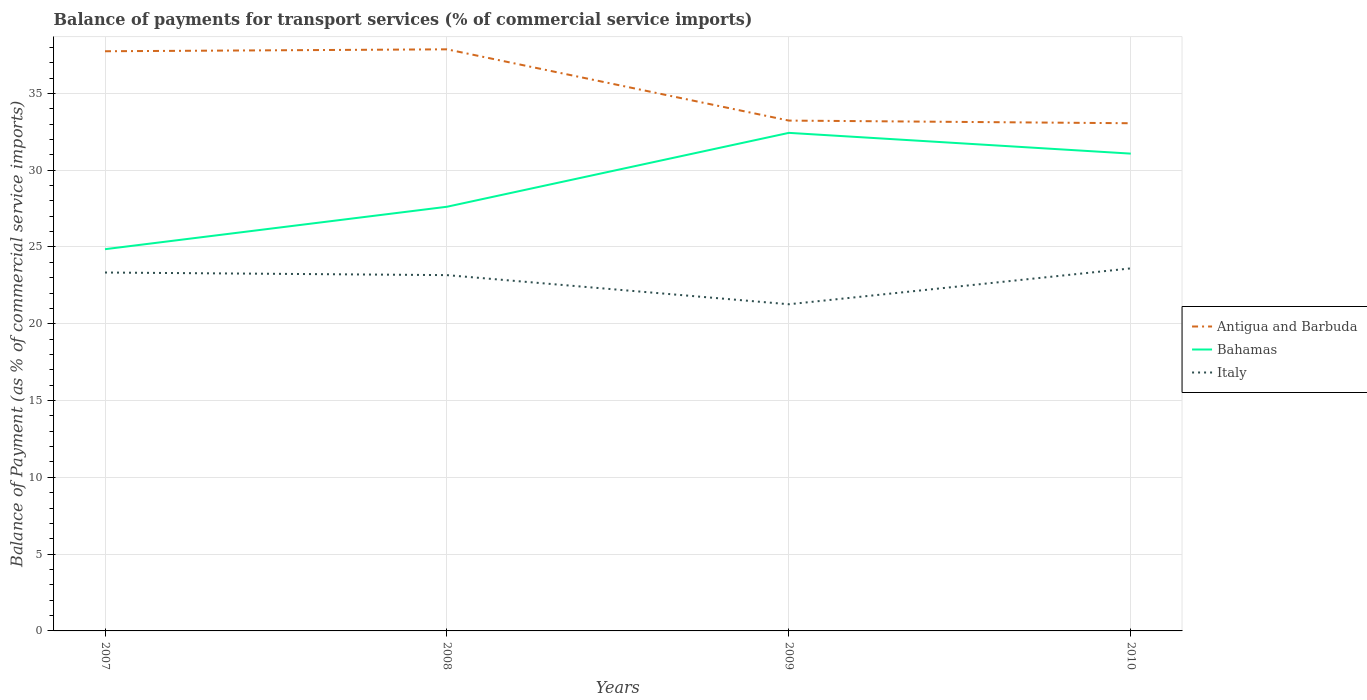How many different coloured lines are there?
Make the answer very short. 3. Does the line corresponding to Bahamas intersect with the line corresponding to Antigua and Barbuda?
Ensure brevity in your answer.  No. Across all years, what is the maximum balance of payments for transport services in Bahamas?
Your answer should be very brief. 24.85. In which year was the balance of payments for transport services in Bahamas maximum?
Offer a terse response. 2007. What is the total balance of payments for transport services in Bahamas in the graph?
Keep it short and to the point. -3.46. What is the difference between the highest and the second highest balance of payments for transport services in Italy?
Your answer should be compact. 2.34. What is the difference between two consecutive major ticks on the Y-axis?
Ensure brevity in your answer.  5. Does the graph contain any zero values?
Offer a terse response. No. Where does the legend appear in the graph?
Give a very brief answer. Center right. What is the title of the graph?
Your answer should be compact. Balance of payments for transport services (% of commercial service imports). Does "Macao" appear as one of the legend labels in the graph?
Offer a terse response. No. What is the label or title of the Y-axis?
Make the answer very short. Balance of Payment (as % of commercial service imports). What is the Balance of Payment (as % of commercial service imports) of Antigua and Barbuda in 2007?
Your response must be concise. 37.74. What is the Balance of Payment (as % of commercial service imports) of Bahamas in 2007?
Your answer should be compact. 24.85. What is the Balance of Payment (as % of commercial service imports) of Italy in 2007?
Keep it short and to the point. 23.34. What is the Balance of Payment (as % of commercial service imports) of Antigua and Barbuda in 2008?
Offer a terse response. 37.87. What is the Balance of Payment (as % of commercial service imports) in Bahamas in 2008?
Your response must be concise. 27.62. What is the Balance of Payment (as % of commercial service imports) in Italy in 2008?
Offer a very short reply. 23.17. What is the Balance of Payment (as % of commercial service imports) in Antigua and Barbuda in 2009?
Your answer should be very brief. 33.23. What is the Balance of Payment (as % of commercial service imports) of Bahamas in 2009?
Keep it short and to the point. 32.43. What is the Balance of Payment (as % of commercial service imports) in Italy in 2009?
Offer a terse response. 21.27. What is the Balance of Payment (as % of commercial service imports) in Antigua and Barbuda in 2010?
Offer a terse response. 33.05. What is the Balance of Payment (as % of commercial service imports) in Bahamas in 2010?
Keep it short and to the point. 31.08. What is the Balance of Payment (as % of commercial service imports) in Italy in 2010?
Make the answer very short. 23.61. Across all years, what is the maximum Balance of Payment (as % of commercial service imports) of Antigua and Barbuda?
Make the answer very short. 37.87. Across all years, what is the maximum Balance of Payment (as % of commercial service imports) of Bahamas?
Offer a terse response. 32.43. Across all years, what is the maximum Balance of Payment (as % of commercial service imports) in Italy?
Offer a very short reply. 23.61. Across all years, what is the minimum Balance of Payment (as % of commercial service imports) of Antigua and Barbuda?
Offer a terse response. 33.05. Across all years, what is the minimum Balance of Payment (as % of commercial service imports) of Bahamas?
Provide a succinct answer. 24.85. Across all years, what is the minimum Balance of Payment (as % of commercial service imports) in Italy?
Ensure brevity in your answer.  21.27. What is the total Balance of Payment (as % of commercial service imports) in Antigua and Barbuda in the graph?
Your answer should be compact. 141.89. What is the total Balance of Payment (as % of commercial service imports) of Bahamas in the graph?
Your answer should be very brief. 115.98. What is the total Balance of Payment (as % of commercial service imports) of Italy in the graph?
Your answer should be compact. 91.38. What is the difference between the Balance of Payment (as % of commercial service imports) in Antigua and Barbuda in 2007 and that in 2008?
Give a very brief answer. -0.13. What is the difference between the Balance of Payment (as % of commercial service imports) in Bahamas in 2007 and that in 2008?
Your answer should be very brief. -2.76. What is the difference between the Balance of Payment (as % of commercial service imports) in Italy in 2007 and that in 2008?
Provide a short and direct response. 0.17. What is the difference between the Balance of Payment (as % of commercial service imports) in Antigua and Barbuda in 2007 and that in 2009?
Provide a succinct answer. 4.51. What is the difference between the Balance of Payment (as % of commercial service imports) in Bahamas in 2007 and that in 2009?
Your answer should be compact. -7.57. What is the difference between the Balance of Payment (as % of commercial service imports) of Italy in 2007 and that in 2009?
Keep it short and to the point. 2.07. What is the difference between the Balance of Payment (as % of commercial service imports) in Antigua and Barbuda in 2007 and that in 2010?
Your answer should be compact. 4.69. What is the difference between the Balance of Payment (as % of commercial service imports) of Bahamas in 2007 and that in 2010?
Provide a short and direct response. -6.22. What is the difference between the Balance of Payment (as % of commercial service imports) of Italy in 2007 and that in 2010?
Give a very brief answer. -0.27. What is the difference between the Balance of Payment (as % of commercial service imports) in Antigua and Barbuda in 2008 and that in 2009?
Ensure brevity in your answer.  4.64. What is the difference between the Balance of Payment (as % of commercial service imports) of Bahamas in 2008 and that in 2009?
Ensure brevity in your answer.  -4.81. What is the difference between the Balance of Payment (as % of commercial service imports) in Italy in 2008 and that in 2009?
Your response must be concise. 1.9. What is the difference between the Balance of Payment (as % of commercial service imports) of Antigua and Barbuda in 2008 and that in 2010?
Keep it short and to the point. 4.81. What is the difference between the Balance of Payment (as % of commercial service imports) in Bahamas in 2008 and that in 2010?
Give a very brief answer. -3.46. What is the difference between the Balance of Payment (as % of commercial service imports) in Italy in 2008 and that in 2010?
Your answer should be very brief. -0.44. What is the difference between the Balance of Payment (as % of commercial service imports) in Antigua and Barbuda in 2009 and that in 2010?
Provide a succinct answer. 0.17. What is the difference between the Balance of Payment (as % of commercial service imports) of Bahamas in 2009 and that in 2010?
Your answer should be very brief. 1.35. What is the difference between the Balance of Payment (as % of commercial service imports) in Italy in 2009 and that in 2010?
Your response must be concise. -2.34. What is the difference between the Balance of Payment (as % of commercial service imports) of Antigua and Barbuda in 2007 and the Balance of Payment (as % of commercial service imports) of Bahamas in 2008?
Make the answer very short. 10.12. What is the difference between the Balance of Payment (as % of commercial service imports) of Antigua and Barbuda in 2007 and the Balance of Payment (as % of commercial service imports) of Italy in 2008?
Offer a terse response. 14.58. What is the difference between the Balance of Payment (as % of commercial service imports) in Bahamas in 2007 and the Balance of Payment (as % of commercial service imports) in Italy in 2008?
Your answer should be compact. 1.69. What is the difference between the Balance of Payment (as % of commercial service imports) in Antigua and Barbuda in 2007 and the Balance of Payment (as % of commercial service imports) in Bahamas in 2009?
Provide a short and direct response. 5.31. What is the difference between the Balance of Payment (as % of commercial service imports) of Antigua and Barbuda in 2007 and the Balance of Payment (as % of commercial service imports) of Italy in 2009?
Your answer should be compact. 16.47. What is the difference between the Balance of Payment (as % of commercial service imports) in Bahamas in 2007 and the Balance of Payment (as % of commercial service imports) in Italy in 2009?
Keep it short and to the point. 3.58. What is the difference between the Balance of Payment (as % of commercial service imports) of Antigua and Barbuda in 2007 and the Balance of Payment (as % of commercial service imports) of Bahamas in 2010?
Give a very brief answer. 6.67. What is the difference between the Balance of Payment (as % of commercial service imports) of Antigua and Barbuda in 2007 and the Balance of Payment (as % of commercial service imports) of Italy in 2010?
Make the answer very short. 14.14. What is the difference between the Balance of Payment (as % of commercial service imports) in Bahamas in 2007 and the Balance of Payment (as % of commercial service imports) in Italy in 2010?
Offer a terse response. 1.25. What is the difference between the Balance of Payment (as % of commercial service imports) in Antigua and Barbuda in 2008 and the Balance of Payment (as % of commercial service imports) in Bahamas in 2009?
Make the answer very short. 5.44. What is the difference between the Balance of Payment (as % of commercial service imports) in Antigua and Barbuda in 2008 and the Balance of Payment (as % of commercial service imports) in Italy in 2009?
Your response must be concise. 16.6. What is the difference between the Balance of Payment (as % of commercial service imports) in Bahamas in 2008 and the Balance of Payment (as % of commercial service imports) in Italy in 2009?
Your answer should be very brief. 6.35. What is the difference between the Balance of Payment (as % of commercial service imports) in Antigua and Barbuda in 2008 and the Balance of Payment (as % of commercial service imports) in Bahamas in 2010?
Provide a succinct answer. 6.79. What is the difference between the Balance of Payment (as % of commercial service imports) of Antigua and Barbuda in 2008 and the Balance of Payment (as % of commercial service imports) of Italy in 2010?
Offer a very short reply. 14.26. What is the difference between the Balance of Payment (as % of commercial service imports) of Bahamas in 2008 and the Balance of Payment (as % of commercial service imports) of Italy in 2010?
Give a very brief answer. 4.01. What is the difference between the Balance of Payment (as % of commercial service imports) in Antigua and Barbuda in 2009 and the Balance of Payment (as % of commercial service imports) in Bahamas in 2010?
Your answer should be very brief. 2.15. What is the difference between the Balance of Payment (as % of commercial service imports) of Antigua and Barbuda in 2009 and the Balance of Payment (as % of commercial service imports) of Italy in 2010?
Offer a terse response. 9.62. What is the difference between the Balance of Payment (as % of commercial service imports) of Bahamas in 2009 and the Balance of Payment (as % of commercial service imports) of Italy in 2010?
Provide a succinct answer. 8.82. What is the average Balance of Payment (as % of commercial service imports) of Antigua and Barbuda per year?
Provide a short and direct response. 35.47. What is the average Balance of Payment (as % of commercial service imports) in Bahamas per year?
Offer a very short reply. 28.99. What is the average Balance of Payment (as % of commercial service imports) of Italy per year?
Provide a succinct answer. 22.84. In the year 2007, what is the difference between the Balance of Payment (as % of commercial service imports) in Antigua and Barbuda and Balance of Payment (as % of commercial service imports) in Bahamas?
Ensure brevity in your answer.  12.89. In the year 2007, what is the difference between the Balance of Payment (as % of commercial service imports) of Antigua and Barbuda and Balance of Payment (as % of commercial service imports) of Italy?
Offer a terse response. 14.41. In the year 2007, what is the difference between the Balance of Payment (as % of commercial service imports) of Bahamas and Balance of Payment (as % of commercial service imports) of Italy?
Make the answer very short. 1.52. In the year 2008, what is the difference between the Balance of Payment (as % of commercial service imports) in Antigua and Barbuda and Balance of Payment (as % of commercial service imports) in Bahamas?
Make the answer very short. 10.25. In the year 2008, what is the difference between the Balance of Payment (as % of commercial service imports) of Antigua and Barbuda and Balance of Payment (as % of commercial service imports) of Italy?
Make the answer very short. 14.7. In the year 2008, what is the difference between the Balance of Payment (as % of commercial service imports) of Bahamas and Balance of Payment (as % of commercial service imports) of Italy?
Provide a short and direct response. 4.45. In the year 2009, what is the difference between the Balance of Payment (as % of commercial service imports) in Antigua and Barbuda and Balance of Payment (as % of commercial service imports) in Bahamas?
Give a very brief answer. 0.8. In the year 2009, what is the difference between the Balance of Payment (as % of commercial service imports) of Antigua and Barbuda and Balance of Payment (as % of commercial service imports) of Italy?
Offer a very short reply. 11.96. In the year 2009, what is the difference between the Balance of Payment (as % of commercial service imports) of Bahamas and Balance of Payment (as % of commercial service imports) of Italy?
Make the answer very short. 11.16. In the year 2010, what is the difference between the Balance of Payment (as % of commercial service imports) of Antigua and Barbuda and Balance of Payment (as % of commercial service imports) of Bahamas?
Your response must be concise. 1.98. In the year 2010, what is the difference between the Balance of Payment (as % of commercial service imports) in Antigua and Barbuda and Balance of Payment (as % of commercial service imports) in Italy?
Your answer should be very brief. 9.45. In the year 2010, what is the difference between the Balance of Payment (as % of commercial service imports) of Bahamas and Balance of Payment (as % of commercial service imports) of Italy?
Offer a terse response. 7.47. What is the ratio of the Balance of Payment (as % of commercial service imports) of Antigua and Barbuda in 2007 to that in 2008?
Offer a very short reply. 1. What is the ratio of the Balance of Payment (as % of commercial service imports) of Bahamas in 2007 to that in 2008?
Offer a terse response. 0.9. What is the ratio of the Balance of Payment (as % of commercial service imports) in Italy in 2007 to that in 2008?
Your response must be concise. 1.01. What is the ratio of the Balance of Payment (as % of commercial service imports) in Antigua and Barbuda in 2007 to that in 2009?
Your response must be concise. 1.14. What is the ratio of the Balance of Payment (as % of commercial service imports) in Bahamas in 2007 to that in 2009?
Your answer should be very brief. 0.77. What is the ratio of the Balance of Payment (as % of commercial service imports) of Italy in 2007 to that in 2009?
Your response must be concise. 1.1. What is the ratio of the Balance of Payment (as % of commercial service imports) of Antigua and Barbuda in 2007 to that in 2010?
Give a very brief answer. 1.14. What is the ratio of the Balance of Payment (as % of commercial service imports) in Bahamas in 2007 to that in 2010?
Offer a very short reply. 0.8. What is the ratio of the Balance of Payment (as % of commercial service imports) of Italy in 2007 to that in 2010?
Offer a very short reply. 0.99. What is the ratio of the Balance of Payment (as % of commercial service imports) of Antigua and Barbuda in 2008 to that in 2009?
Keep it short and to the point. 1.14. What is the ratio of the Balance of Payment (as % of commercial service imports) in Bahamas in 2008 to that in 2009?
Your response must be concise. 0.85. What is the ratio of the Balance of Payment (as % of commercial service imports) of Italy in 2008 to that in 2009?
Make the answer very short. 1.09. What is the ratio of the Balance of Payment (as % of commercial service imports) of Antigua and Barbuda in 2008 to that in 2010?
Your answer should be compact. 1.15. What is the ratio of the Balance of Payment (as % of commercial service imports) in Bahamas in 2008 to that in 2010?
Your answer should be compact. 0.89. What is the ratio of the Balance of Payment (as % of commercial service imports) in Italy in 2008 to that in 2010?
Provide a short and direct response. 0.98. What is the ratio of the Balance of Payment (as % of commercial service imports) of Antigua and Barbuda in 2009 to that in 2010?
Offer a very short reply. 1.01. What is the ratio of the Balance of Payment (as % of commercial service imports) of Bahamas in 2009 to that in 2010?
Provide a short and direct response. 1.04. What is the ratio of the Balance of Payment (as % of commercial service imports) of Italy in 2009 to that in 2010?
Ensure brevity in your answer.  0.9. What is the difference between the highest and the second highest Balance of Payment (as % of commercial service imports) in Antigua and Barbuda?
Offer a terse response. 0.13. What is the difference between the highest and the second highest Balance of Payment (as % of commercial service imports) in Bahamas?
Offer a terse response. 1.35. What is the difference between the highest and the second highest Balance of Payment (as % of commercial service imports) in Italy?
Make the answer very short. 0.27. What is the difference between the highest and the lowest Balance of Payment (as % of commercial service imports) in Antigua and Barbuda?
Give a very brief answer. 4.81. What is the difference between the highest and the lowest Balance of Payment (as % of commercial service imports) of Bahamas?
Ensure brevity in your answer.  7.57. What is the difference between the highest and the lowest Balance of Payment (as % of commercial service imports) of Italy?
Give a very brief answer. 2.34. 